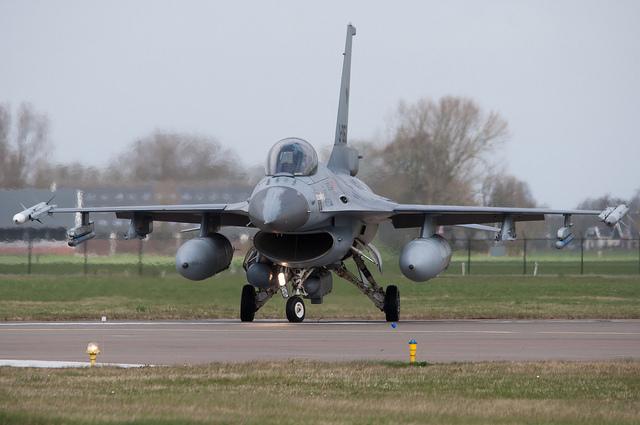Is the plane taking off or landing?
Keep it brief. Taking off. Does this airplane have propellers?
Short answer required. No. What is behind plane in picture?
Be succinct. Fence. 